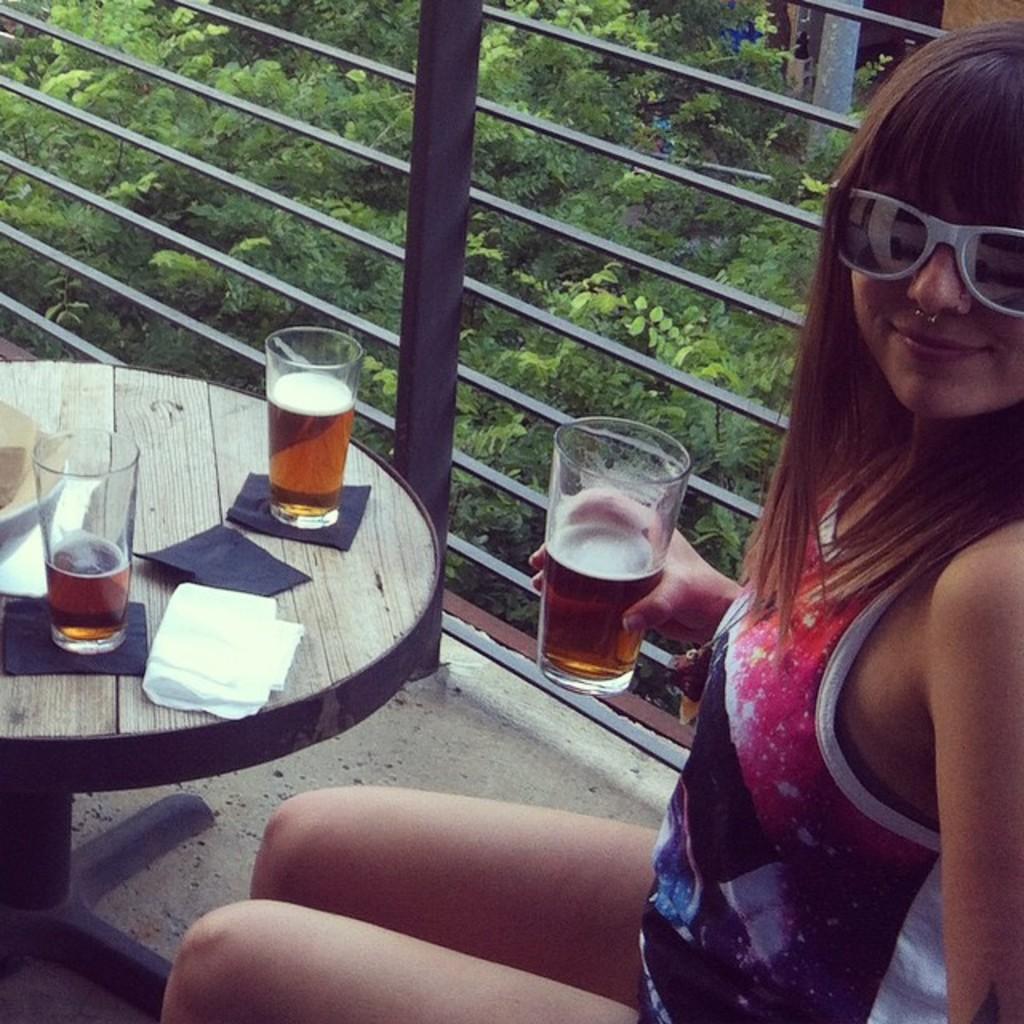Can you describe this image briefly? One lady is sitting and wearing a white goggles and holding a glass containing bear. In front of her there is a table and on the table there is tissue and two glasses. Behind her one railings and some trees are there. 